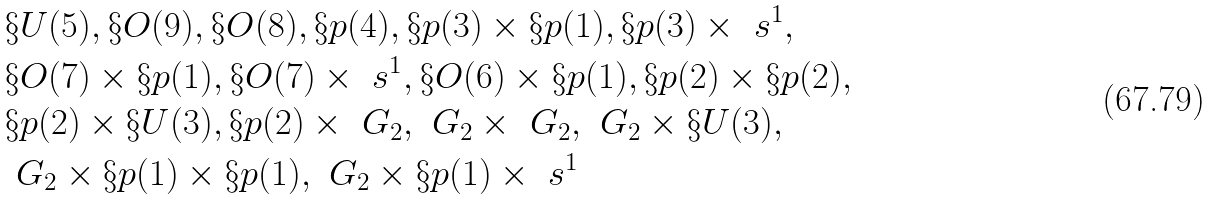Convert formula to latex. <formula><loc_0><loc_0><loc_500><loc_500>& \S U ( 5 ) , \S O ( 9 ) , \S O ( 8 ) , \S p ( 4 ) , \S p ( 3 ) \times \S p ( 1 ) , \S p ( 3 ) \times \ s ^ { 1 } , \\ & \S O ( 7 ) \times \S p ( 1 ) , \S O ( 7 ) \times \ s ^ { 1 } , \S O ( 6 ) \times \S p ( 1 ) , \S p ( 2 ) \times \S p ( 2 ) , \\ & \S p ( 2 ) \times \S U ( 3 ) , \S p ( 2 ) \times \ G _ { 2 } , \ G _ { 2 } \times \ G _ { 2 } , \ G _ { 2 } \times \S U ( 3 ) , \\ & \ G _ { 2 } \times \S p ( 1 ) \times \S p ( 1 ) , \ G _ { 2 } \times \S p ( 1 ) \times \ s ^ { 1 }</formula> 